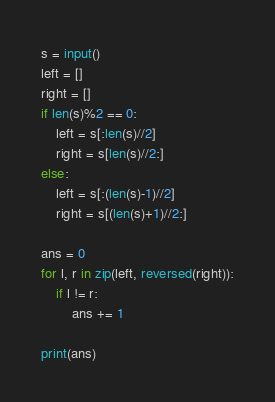Convert code to text. <code><loc_0><loc_0><loc_500><loc_500><_Python_>s = input()
left = []
right = []
if len(s)%2 == 0:
    left = s[:len(s)//2]
    right = s[len(s)//2:]
else:
    left = s[:(len(s)-1)//2]
    right = s[(len(s)+1)//2:]

ans = 0
for l, r in zip(left, reversed(right)):
    if l != r:
        ans += 1

print(ans)
</code> 